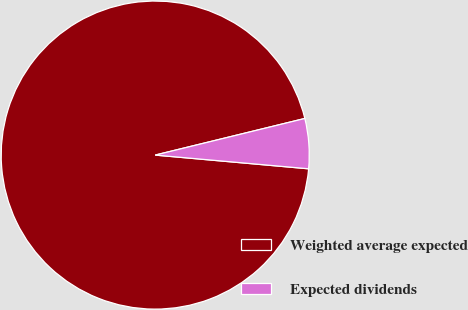Convert chart. <chart><loc_0><loc_0><loc_500><loc_500><pie_chart><fcel>Weighted average expected<fcel>Expected dividends<nl><fcel>94.76%<fcel>5.24%<nl></chart> 